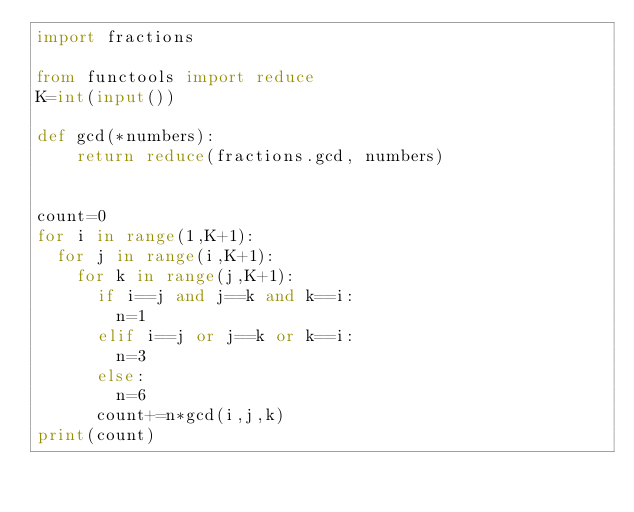<code> <loc_0><loc_0><loc_500><loc_500><_Python_>import fractions

from functools import reduce
K=int(input())

def gcd(*numbers):
    return reduce(fractions.gcd, numbers)


count=0
for i in range(1,K+1):
  for j in range(i,K+1):
    for k in range(j,K+1):
      if i==j and j==k and k==i:
        n=1
      elif i==j or j==k or k==i:
        n=3
      else:
        n=6
      count+=n*gcd(i,j,k)
print(count)</code> 